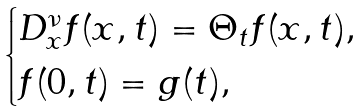Convert formula to latex. <formula><loc_0><loc_0><loc_500><loc_500>\begin{cases} D _ { x } ^ { \nu } f ( x , t ) = \Theta _ { t } f ( x , t ) , \\ f ( 0 , t ) = g ( t ) , \end{cases}</formula> 